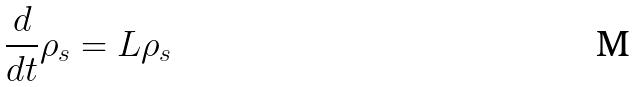Convert formula to latex. <formula><loc_0><loc_0><loc_500><loc_500>\frac { d } { d t } \rho _ { s } = L \rho _ { s }</formula> 